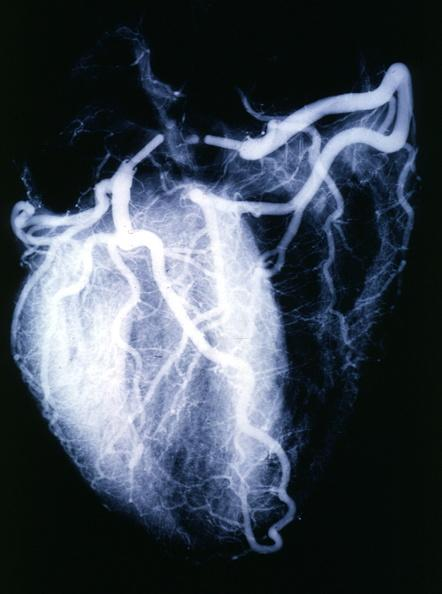s atrophy present?
Answer the question using a single word or phrase. No 